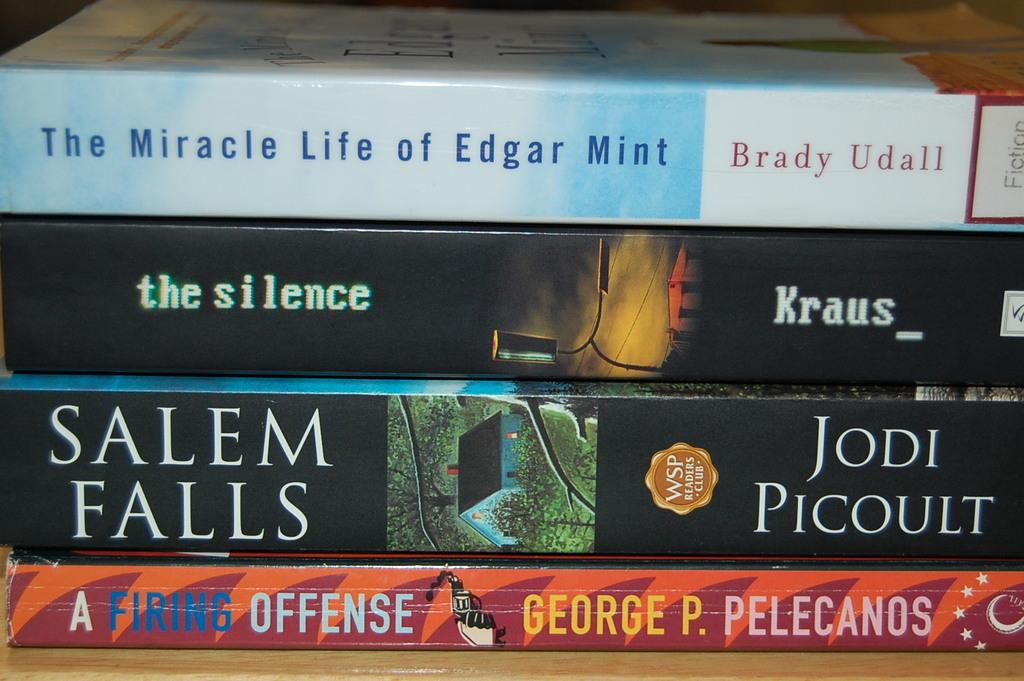<image>
Offer a succinct explanation of the picture presented. A book by Jodi Picoult is called Salem Falls. 